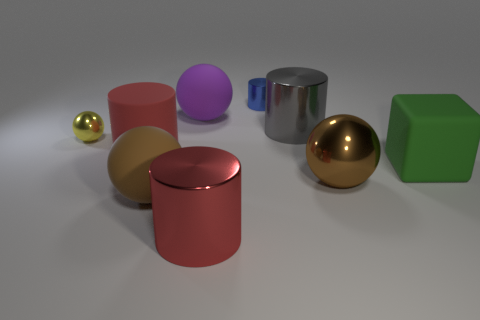Imagine these objects are part of a toy set, what kind of game could you create using them? These objects could be used in a creative building and balance game. Players could take turns stacking objects on top of each other to create structures without making them fall. The variety of shapes and textures would make for an interesting challenge in strategizing the best way to balance each piece. 